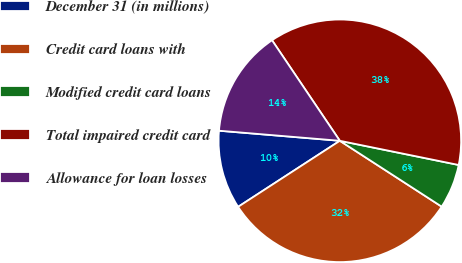Convert chart to OTSL. <chart><loc_0><loc_0><loc_500><loc_500><pie_chart><fcel>December 31 (in millions)<fcel>Credit card loans with<fcel>Modified credit card loans<fcel>Total impaired credit card<fcel>Allowance for loan losses<nl><fcel>10.49%<fcel>31.7%<fcel>5.94%<fcel>37.64%<fcel>14.23%<nl></chart> 